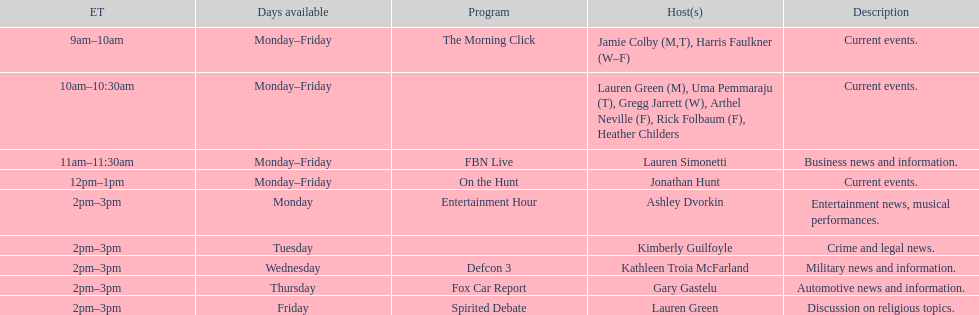Which program can exclusively be accessed on thursdays? Fox Car Report. 